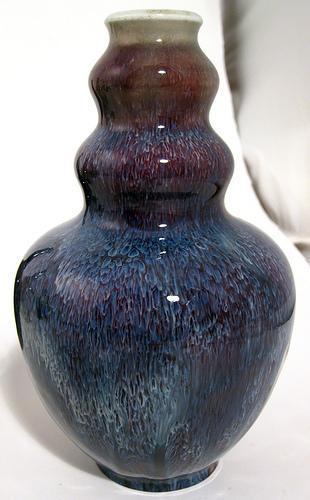How many pots are there?
Give a very brief answer. 1. 